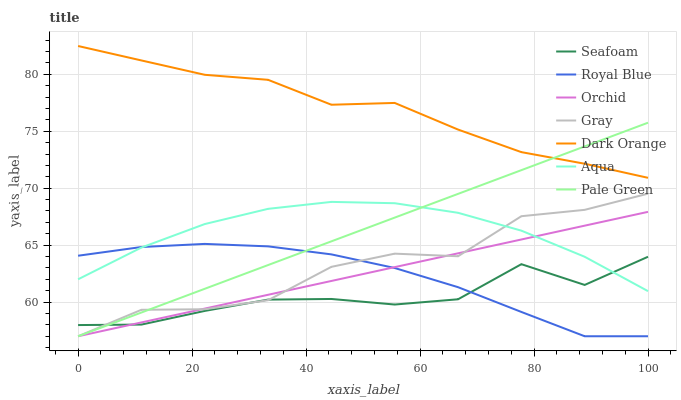Does Seafoam have the minimum area under the curve?
Answer yes or no. Yes. Does Dark Orange have the maximum area under the curve?
Answer yes or no. Yes. Does Gray have the minimum area under the curve?
Answer yes or no. No. Does Gray have the maximum area under the curve?
Answer yes or no. No. Is Orchid the smoothest?
Answer yes or no. Yes. Is Gray the roughest?
Answer yes or no. Yes. Is Aqua the smoothest?
Answer yes or no. No. Is Aqua the roughest?
Answer yes or no. No. Does Gray have the lowest value?
Answer yes or no. Yes. Does Aqua have the lowest value?
Answer yes or no. No. Does Dark Orange have the highest value?
Answer yes or no. Yes. Does Gray have the highest value?
Answer yes or no. No. Is Seafoam less than Dark Orange?
Answer yes or no. Yes. Is Dark Orange greater than Aqua?
Answer yes or no. Yes. Does Gray intersect Royal Blue?
Answer yes or no. Yes. Is Gray less than Royal Blue?
Answer yes or no. No. Is Gray greater than Royal Blue?
Answer yes or no. No. Does Seafoam intersect Dark Orange?
Answer yes or no. No. 